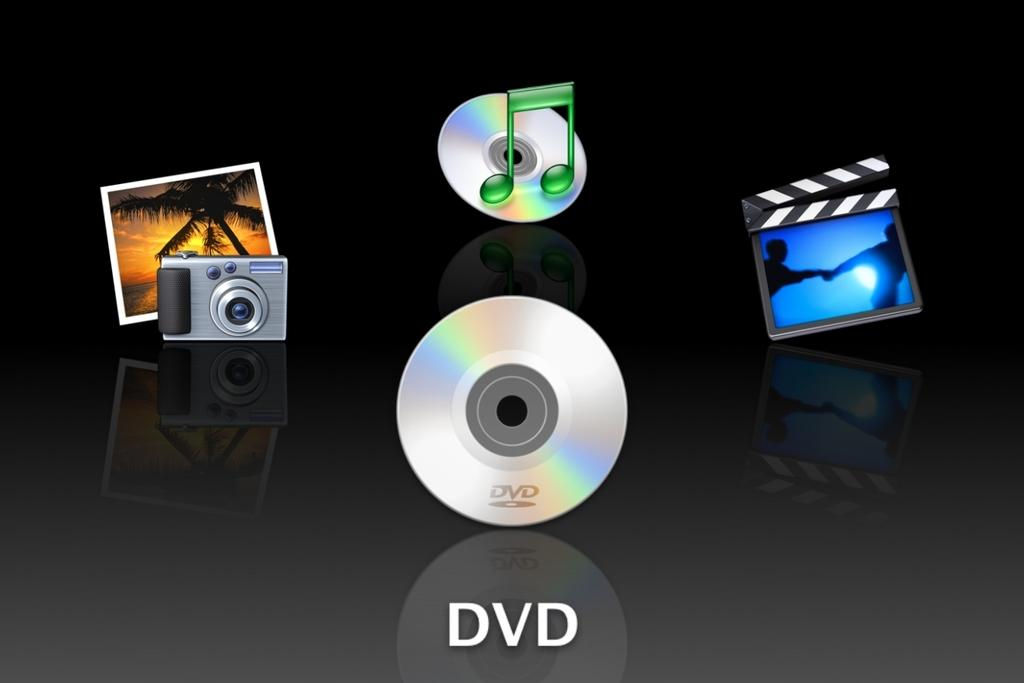What type of media is present in the image? There are DVDs in the image. What device is visible in the image? There is a camera in the image. What object is used for displaying photos in the image? There is a photo frame in the image. What brand or company is represented by the logo in the image? The music logo in the image represents a brand or company related to music. What color is the background of the image? The background of the image is black. How many fingers can be seen using the calculator in the image? There is no calculator or fingers present in the image. What type of step is shown in the image? There is no step or staircase present in the image. 